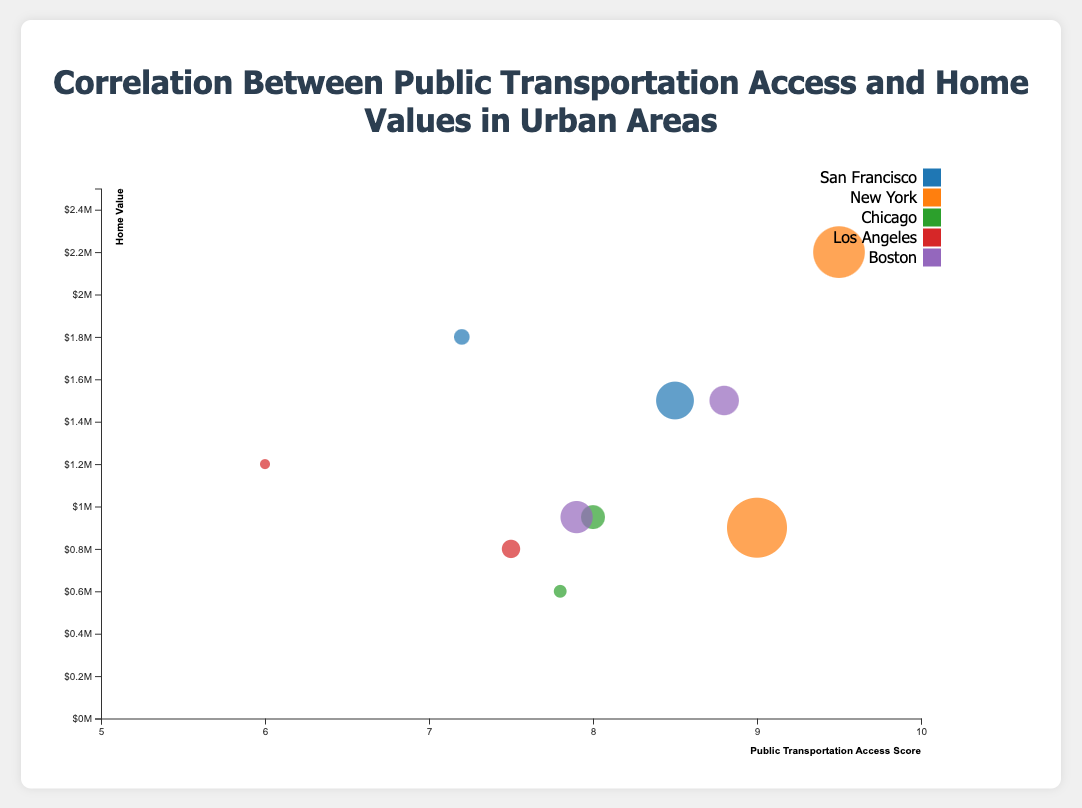What is the title of the chart? The title is displayed at the top center of the chart in large, bold text. It reads "Correlation Between Public Transportation Access and Home Values in Urban Areas."
Answer: Correlation Between Public Transportation Access and Home Values in Urban Areas How many cities are represented in the chart? Each city is color-coded uniquely. There are five different colors, each representing a different city.
Answer: 5 Which city has the neighborhood with the highest home value? By observing the y-axis, which represents home values, and identifying the highest point, we see that it corresponds to Greenwich Village in New York.
Answer: New York What is the home value of Harlem in New York? Locate Harlem in New York by identifying the label in the tooltip. The circle representing Harlem corresponds to a home value slightly below $1,000,000, as indicated by the y-axis.
Answer: $900,000 Is there a general trend between public transportation access and home values? Observing the overall distribution, neighborhoods with higher public transportation access scores generally tend to have higher home values, indicating a positive correlation.
Answer: Positive correlation How does the home value in Mission District, San Francisco compare to that in Harlem, New York? Locate both neighborhoods on the chart and compare their y-coordinate values. Mission District has a higher y-coordinate than Harlem, indicating a higher home value.
Answer: Higher Which neighborhood has the highest public transportation access score? By observing the x-axis and identifying the furthest point to the right, this corresponds to Greenwich Village in New York with a score of 9.5.
Answer: Greenwich Village What is the population density of Lincoln Park, Chicago, and how do you know? Hover over the circle representing Lincoln Park in the tooltip. It shows a population density of 15,000 people per square kilometer.
Answer: 15,000/km² Which city has the lowest home value, and what is that value? Locate the lowest point on the y-axis and observe its city label through color coding or the tooltip. It belongs to Hyde Park in Chicago with a home value of $600,000.
Answer: Chicago, $600,000 Which neighborhood has the largest circle, and what does it represent? Identify the largest circle using size, which represents the highest population density. The largest circle corresponds to Harlem, New York with a population density of 28,000 people per square kilometer.
Answer: Harlem, Population Density 